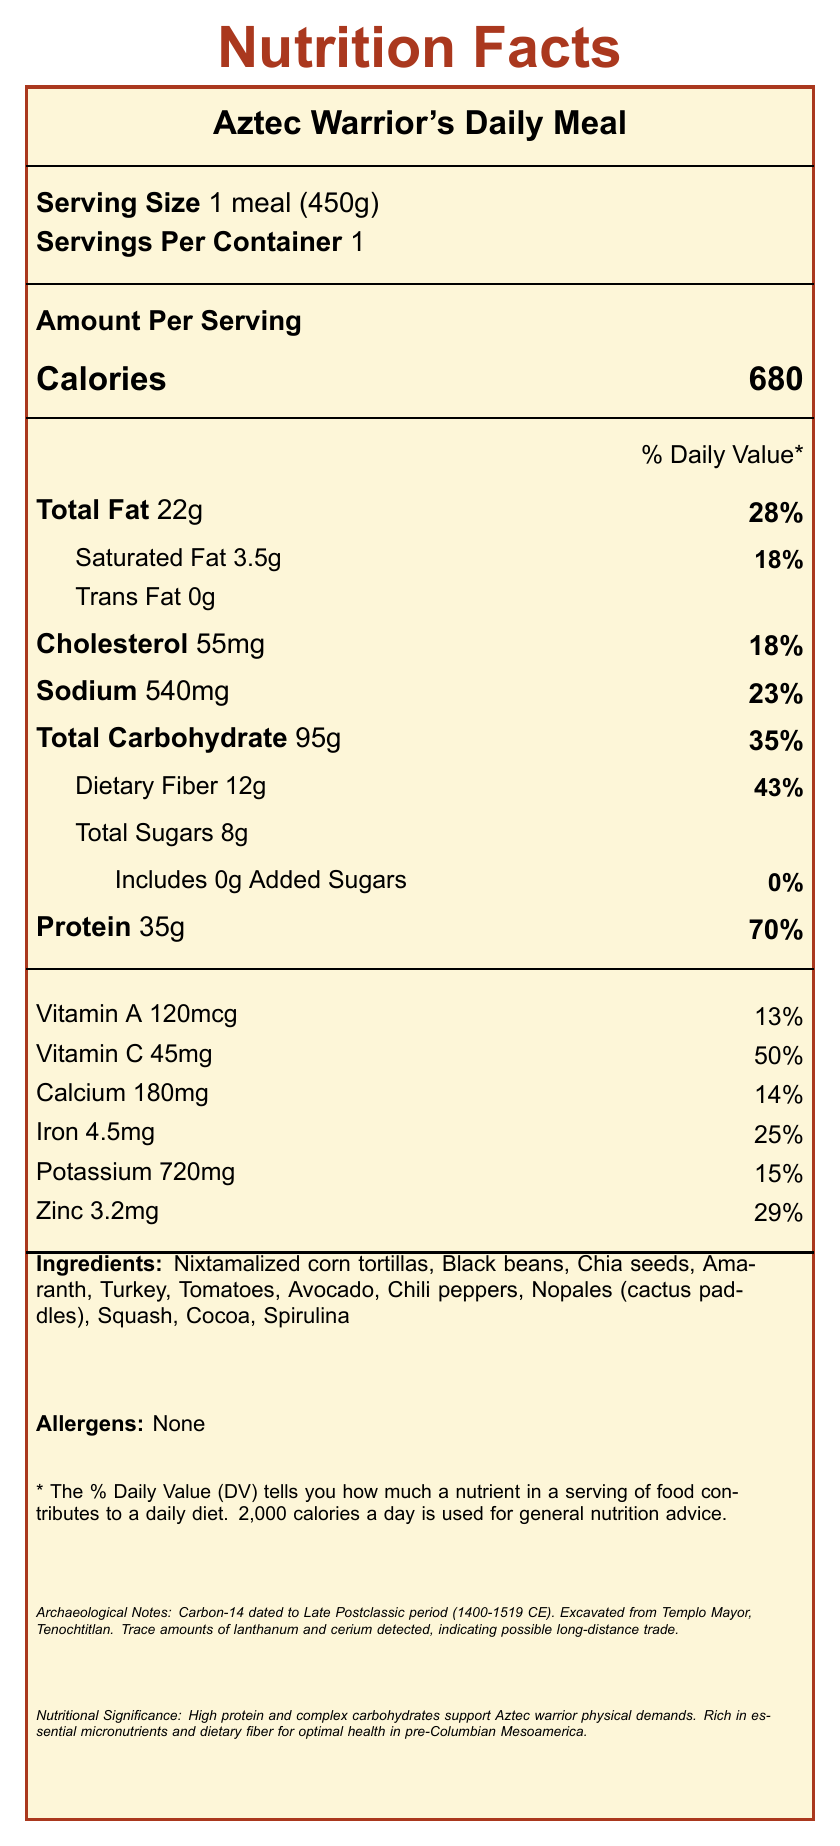What is the serving size for the Aztec Warrior's Daily Meal? The serving size information is provided as "1 meal (450g)" in the document.
Answer: 1 meal (450g) What percentage of the daily value for protein does the meal provide? The document states that the protein content per serving is 35g, which provides 70% of the daily value.
Answer: 70% How much total carbohydrate is in one serving? The document lists the total carbohydrate content as 95g per serving.
Answer: 95g Which vitamin has the highest percentage of daily value in the meal? The document lists vitamin C's daily value percentage as 50%, which is the highest among the vitamins listed.
Answer: Vitamin C What allergens are present in the meal? The document explicitly states that there are no allergens present in the meal.
Answer: None Which ingredients are used in the Aztec Warrior's Daily Meal? A. Black beans, Spirulina, Potatoes B. Nixtamalized corn tortillas, Black beans, Avocado C. Turkey, Amaranth, Peanuts The list of ingredients includes Nixtamalized corn tortillas, Black beans, and Avocado, but not Potatoes or Peanuts.
Answer: B What is the percentage of daily value for iron provided by this meal? A. 14% B. 18% C. 25% The document states that the iron content is 4.5mg, which corresponds to 25% of the daily value.
Answer: C Is trans fat present in the meal? The document lists the trans fat content as 0g, indicating that there is no trans fat in the meal.
Answer: No Summarize the nutritional significance of the Aztec Warrior's Daily Meal The document highlights the meal's high protein, complex carbohydrates, rich micronutrient density, and dietary fiber, all of which contribute to the physical and health needs of Aztec warriors in pre-Columbian Mesoamerica.
Answer: The meal is high in protein, complex carbohydrates, and essential micronutrients such as iron and zinc, which support the physical demands and health of Aztec warriors. It also has high dietary fiber content to promote digestive health. What is the carbon-14 dating estimate for the meal period? The carbon-14 dating of organic residues on pottery places the meal in the Late Postclassic period (1400-1519 CE).
Answer: Late Postclassic period (1400-1519 CE) Which archaeological site was this meal excavated from? The document states that the meal was excavated from Templo Mayor, Tenochtitlan.
Answer: Templo Mayor, Tenochtitlan What is the total calorie content of the Aztec Warrior's Daily Meal? The calorie content information states that the meal contains 680 calories per serving.
Answer: 680 calories Are trace amounts of rare earth elements found in the meal? The document mentions trace amounts of lanthanum and cerium detected in pottery, suggesting possible trade with distant regions.
Answer: Yes How much dietary fiber does one serving of the meal contain? The dietary fiber content is listed as 12g per serving.
Answer: 12g What was the main source of protein in the Aztec Warrior's Daily Meal? The nutritional significance section specifies that high protein content comes from turkey, beans, and amaranth.
Answer: Turkey, beans, and amaranth How does the meal support the physical demands of Aztec warriors? The document explains that the high protein content and complex carbohydrates from the meal provide the necessary energy and nutrition to support the physical demands of Aztec warriors.
Answer: High protein and complex carbohydrates 